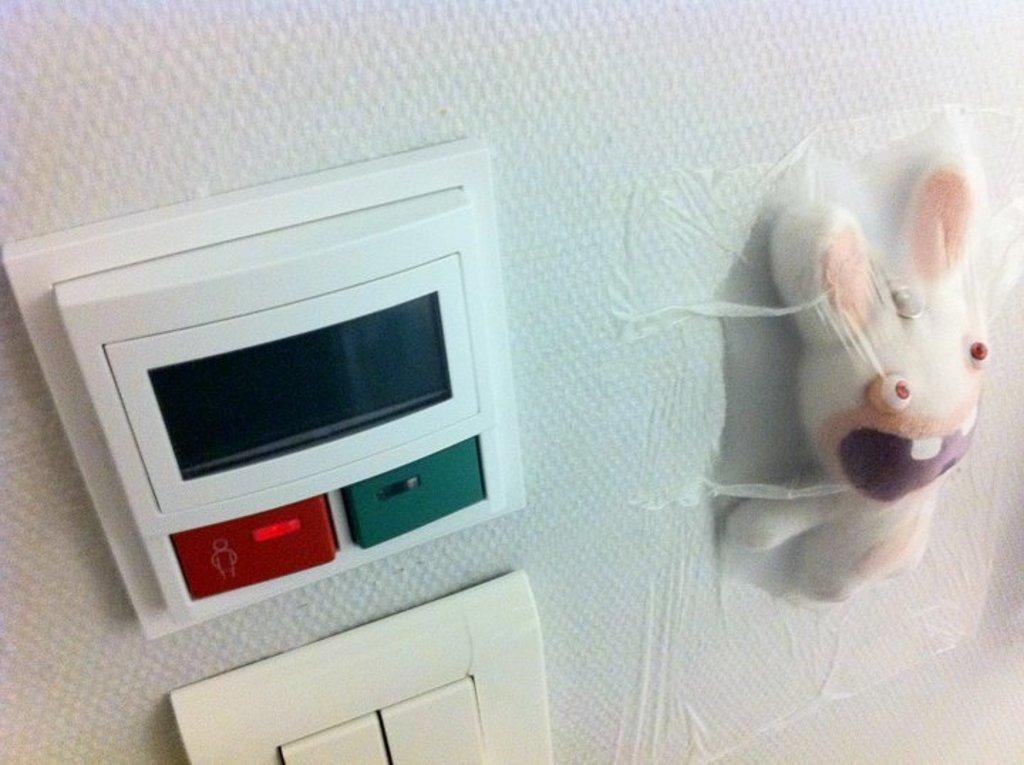What type of buttons are visible in the image? There are power buttons in the image. Can you describe the unusual placement of an object in the image? Yes, there is a soft toy stuck to the wall in the image. Who is the manager of the girls in the image? There are no girls or a manager present in the image. 